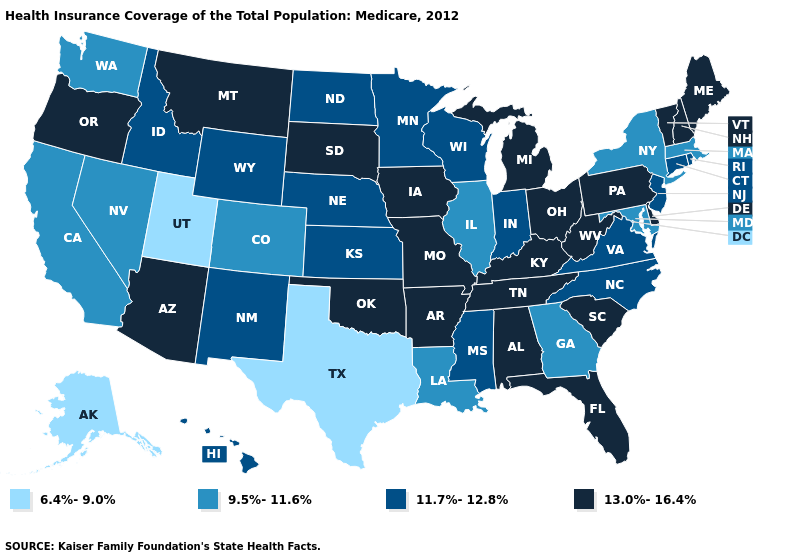Name the states that have a value in the range 13.0%-16.4%?
Answer briefly. Alabama, Arizona, Arkansas, Delaware, Florida, Iowa, Kentucky, Maine, Michigan, Missouri, Montana, New Hampshire, Ohio, Oklahoma, Oregon, Pennsylvania, South Carolina, South Dakota, Tennessee, Vermont, West Virginia. What is the lowest value in the USA?
Concise answer only. 6.4%-9.0%. What is the highest value in the Northeast ?
Keep it brief. 13.0%-16.4%. Name the states that have a value in the range 6.4%-9.0%?
Concise answer only. Alaska, Texas, Utah. Among the states that border Indiana , which have the lowest value?
Short answer required. Illinois. What is the value of Maine?
Concise answer only. 13.0%-16.4%. Which states hav the highest value in the MidWest?
Be succinct. Iowa, Michigan, Missouri, Ohio, South Dakota. What is the value of Idaho?
Be succinct. 11.7%-12.8%. What is the value of New York?
Concise answer only. 9.5%-11.6%. Name the states that have a value in the range 6.4%-9.0%?
Concise answer only. Alaska, Texas, Utah. Does Illinois have the lowest value in the MidWest?
Concise answer only. Yes. Does Virginia have the highest value in the South?
Be succinct. No. Does Hawaii have a higher value than Virginia?
Keep it brief. No. What is the value of New Hampshire?
Concise answer only. 13.0%-16.4%. What is the value of Wisconsin?
Short answer required. 11.7%-12.8%. 